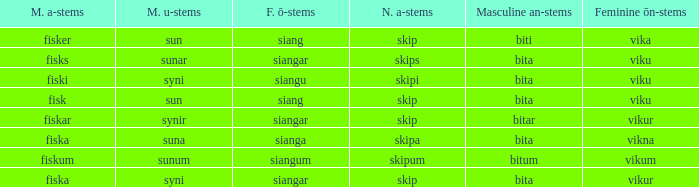What is the an-stem for the word which has an ö-stems of siangar and an u-stem ending of syni? Bita. 